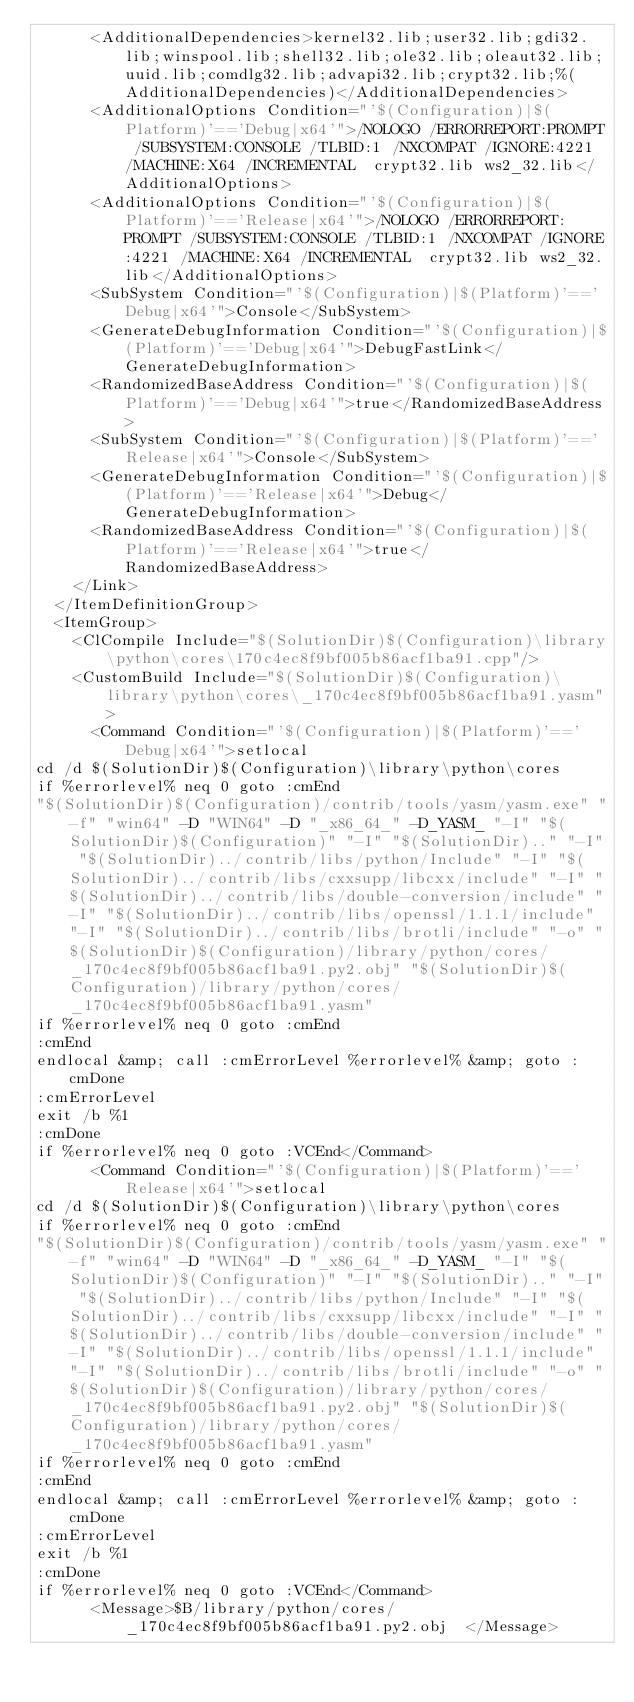Convert code to text. <code><loc_0><loc_0><loc_500><loc_500><_XML_>      <AdditionalDependencies>kernel32.lib;user32.lib;gdi32.lib;winspool.lib;shell32.lib;ole32.lib;oleaut32.lib;uuid.lib;comdlg32.lib;advapi32.lib;crypt32.lib;%(AdditionalDependencies)</AdditionalDependencies>
      <AdditionalOptions Condition="'$(Configuration)|$(Platform)'=='Debug|x64'">/NOLOGO /ERRORREPORT:PROMPT /SUBSYSTEM:CONSOLE /TLBID:1 /NXCOMPAT /IGNORE:4221 /MACHINE:X64 /INCREMENTAL  crypt32.lib ws2_32.lib</AdditionalOptions>
      <AdditionalOptions Condition="'$(Configuration)|$(Platform)'=='Release|x64'">/NOLOGO /ERRORREPORT:PROMPT /SUBSYSTEM:CONSOLE /TLBID:1 /NXCOMPAT /IGNORE:4221 /MACHINE:X64 /INCREMENTAL  crypt32.lib ws2_32.lib</AdditionalOptions>
      <SubSystem Condition="'$(Configuration)|$(Platform)'=='Debug|x64'">Console</SubSystem>
      <GenerateDebugInformation Condition="'$(Configuration)|$(Platform)'=='Debug|x64'">DebugFastLink</GenerateDebugInformation>
      <RandomizedBaseAddress Condition="'$(Configuration)|$(Platform)'=='Debug|x64'">true</RandomizedBaseAddress>
      <SubSystem Condition="'$(Configuration)|$(Platform)'=='Release|x64'">Console</SubSystem>
      <GenerateDebugInformation Condition="'$(Configuration)|$(Platform)'=='Release|x64'">Debug</GenerateDebugInformation>
      <RandomizedBaseAddress Condition="'$(Configuration)|$(Platform)'=='Release|x64'">true</RandomizedBaseAddress>
    </Link>
  </ItemDefinitionGroup>
  <ItemGroup>
    <ClCompile Include="$(SolutionDir)$(Configuration)\library\python\cores\170c4ec8f9bf005b86acf1ba91.cpp"/>
    <CustomBuild Include="$(SolutionDir)$(Configuration)\library\python\cores\_170c4ec8f9bf005b86acf1ba91.yasm">
      <Command Condition="'$(Configuration)|$(Platform)'=='Debug|x64'">setlocal
cd /d $(SolutionDir)$(Configuration)\library\python\cores
if %errorlevel% neq 0 goto :cmEnd
"$(SolutionDir)$(Configuration)/contrib/tools/yasm/yasm.exe" "-f" "win64" -D "WIN64" -D "_x86_64_" -D_YASM_ "-I" "$(SolutionDir)$(Configuration)" "-I" "$(SolutionDir).." "-I" "$(SolutionDir)../contrib/libs/python/Include" "-I" "$(SolutionDir)../contrib/libs/cxxsupp/libcxx/include" "-I" "$(SolutionDir)../contrib/libs/double-conversion/include" "-I" "$(SolutionDir)../contrib/libs/openssl/1.1.1/include" "-I" "$(SolutionDir)../contrib/libs/brotli/include" "-o" "$(SolutionDir)$(Configuration)/library/python/cores/_170c4ec8f9bf005b86acf1ba91.py2.obj" "$(SolutionDir)$(Configuration)/library/python/cores/_170c4ec8f9bf005b86acf1ba91.yasm"
if %errorlevel% neq 0 goto :cmEnd
:cmEnd
endlocal &amp; call :cmErrorLevel %errorlevel% &amp; goto :cmDone
:cmErrorLevel
exit /b %1
:cmDone
if %errorlevel% neq 0 goto :VCEnd</Command>
      <Command Condition="'$(Configuration)|$(Platform)'=='Release|x64'">setlocal
cd /d $(SolutionDir)$(Configuration)\library\python\cores
if %errorlevel% neq 0 goto :cmEnd
"$(SolutionDir)$(Configuration)/contrib/tools/yasm/yasm.exe" "-f" "win64" -D "WIN64" -D "_x86_64_" -D_YASM_ "-I" "$(SolutionDir)$(Configuration)" "-I" "$(SolutionDir).." "-I" "$(SolutionDir)../contrib/libs/python/Include" "-I" "$(SolutionDir)../contrib/libs/cxxsupp/libcxx/include" "-I" "$(SolutionDir)../contrib/libs/double-conversion/include" "-I" "$(SolutionDir)../contrib/libs/openssl/1.1.1/include" "-I" "$(SolutionDir)../contrib/libs/brotli/include" "-o" "$(SolutionDir)$(Configuration)/library/python/cores/_170c4ec8f9bf005b86acf1ba91.py2.obj" "$(SolutionDir)$(Configuration)/library/python/cores/_170c4ec8f9bf005b86acf1ba91.yasm"
if %errorlevel% neq 0 goto :cmEnd
:cmEnd
endlocal &amp; call :cmErrorLevel %errorlevel% &amp; goto :cmDone
:cmErrorLevel
exit /b %1
:cmDone
if %errorlevel% neq 0 goto :VCEnd</Command>
      <Message>$B/library/python/cores/_170c4ec8f9bf005b86acf1ba91.py2.obj	</Message></code> 